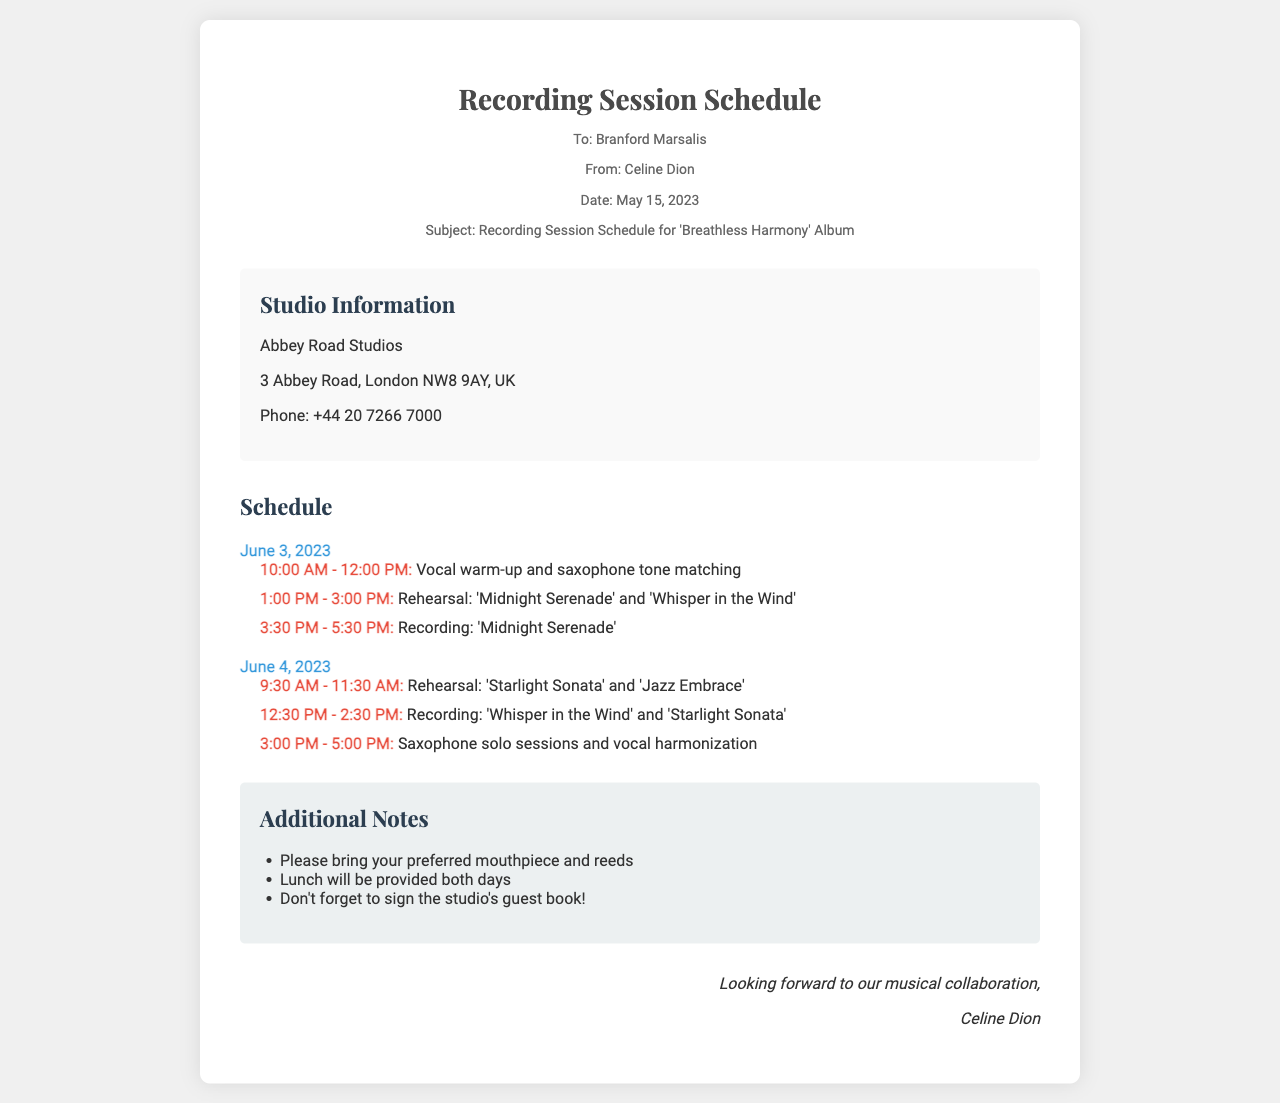What is the date of the recording session? The date for the recording session is mentioned in the document as June 3, 2023, and June 4, 2023.
Answer: June 3, 2023 and June 4, 2023 Who is the saxophonist mentioned in the fax? The fax addresses the renowned saxophonist as Branford Marsalis.
Answer: Branford Marsalis What is the studio location for the recording session? The studio information section in the document specifies Abbey Road Studios as the location.
Answer: Abbey Road Studios What time is the vocal warm-up scheduled for? The schedule lists the vocal warm-up and saxophone tone matching from 10:00 AM to 12:00 PM.
Answer: 10:00 AM - 12:00 PM What is one item vocalists are requested to bring? The additional notes section specifies that vocalists should bring their preferred mouthpiece and reeds.
Answer: Mouthpiece and reeds How many recording sessions are scheduled in total? There are two recording sessions scheduled, one on each day of June 3 and June 4, 2023.
Answer: Two What meals will be provided during the recording session? The additional notes mention that lunch will be provided both days.
Answer: Lunch What is the main subject of the fax? The subject line in the header mentions that this fax is regarding the Recording Session Schedule for the 'Breathless Harmony' Album.
Answer: Recording Session Schedule for 'Breathless Harmony' Album 